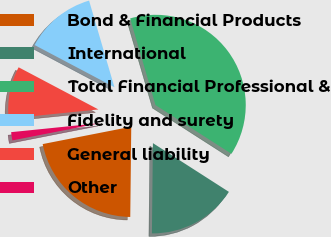<chart> <loc_0><loc_0><loc_500><loc_500><pie_chart><fcel>Bond & Financial Products<fcel>International<fcel>Total Financial Professional &<fcel>Fidelity and surety<fcel>General liability<fcel>Other<nl><fcel>21.74%<fcel>16.1%<fcel>38.61%<fcel>12.73%<fcel>9.35%<fcel>1.47%<nl></chart> 